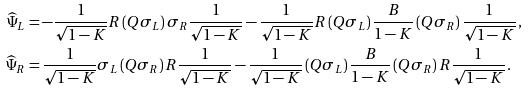<formula> <loc_0><loc_0><loc_500><loc_500>\widehat { \Psi } _ { L } & = - \frac { 1 } { \sqrt { 1 - K } } R \left ( Q \sigma _ { L } \right ) \sigma _ { R } \frac { 1 } { \sqrt { 1 - K } } - \frac { 1 } { \sqrt { 1 - K } } R \left ( Q \sigma _ { L } \right ) \frac { B } { 1 - K } \left ( Q \sigma _ { R } \right ) \frac { 1 } { \sqrt { 1 - K } } \, , \\ \widehat { \Psi } _ { R } & = \frac { 1 } { \sqrt { 1 - K } } \sigma _ { L } \left ( Q \sigma _ { R } \right ) R \frac { 1 } { \sqrt { 1 - K } } - \frac { 1 } { \sqrt { 1 - K } } \left ( Q \sigma _ { L } \right ) \frac { B } { 1 - K } \left ( Q \sigma _ { R } \right ) R \frac { 1 } { \sqrt { 1 - K } } \, .</formula> 